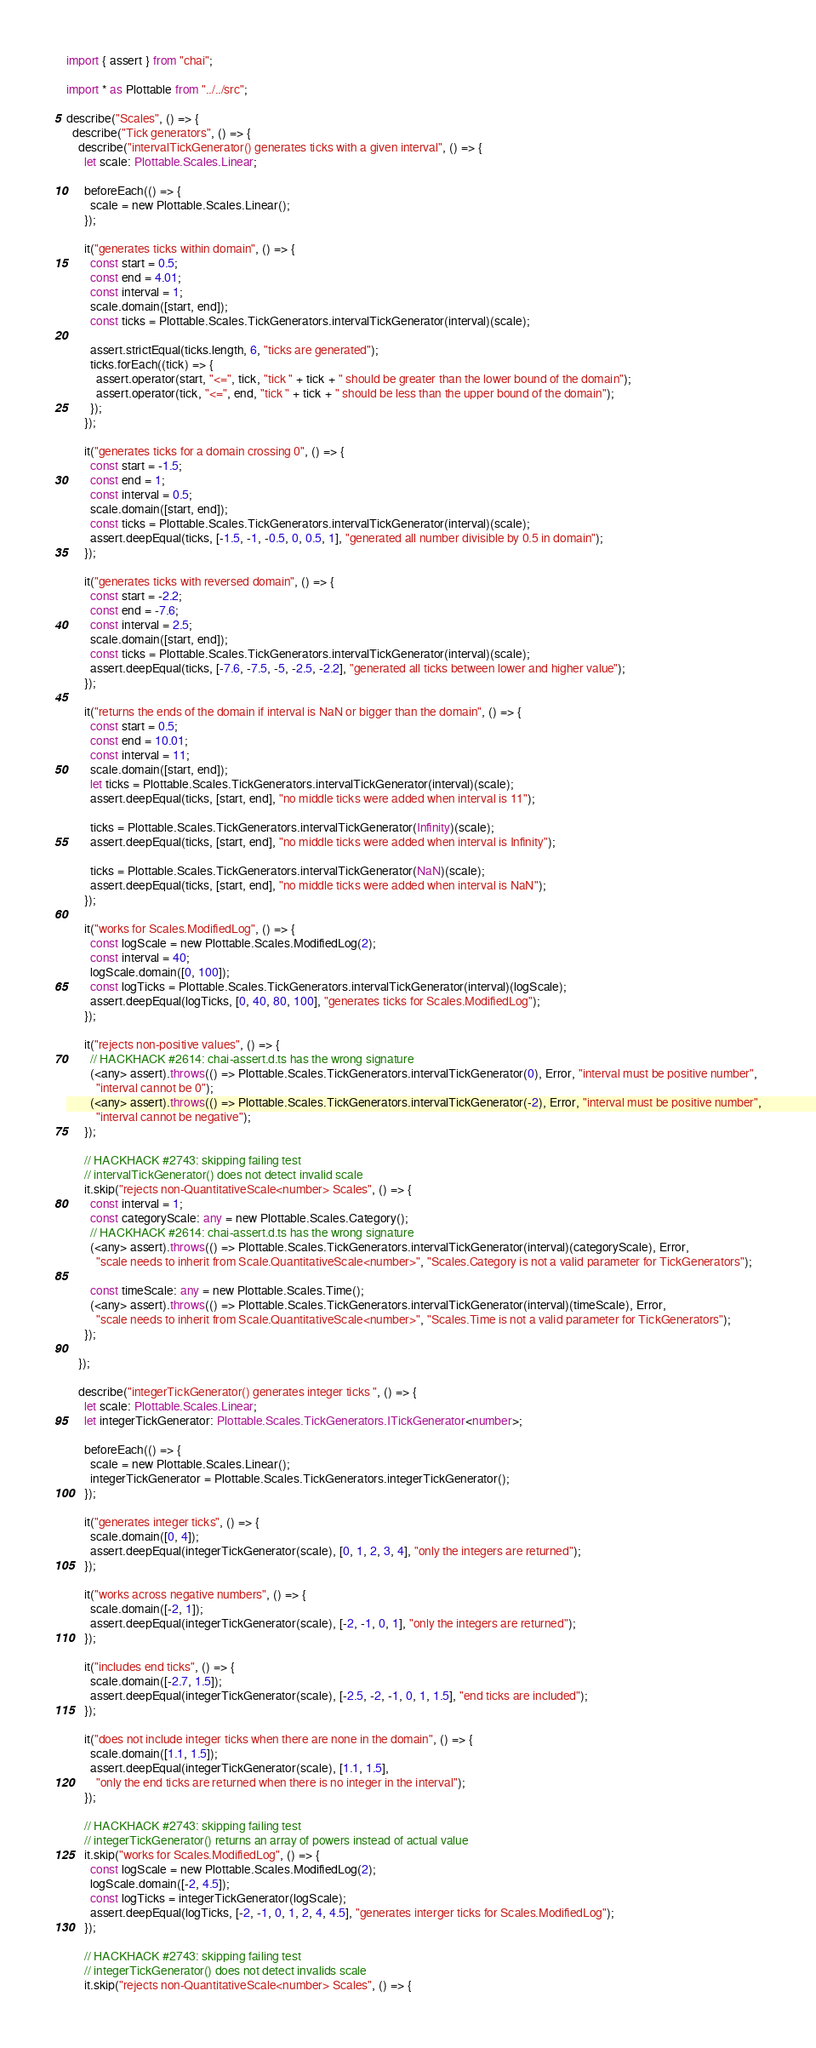<code> <loc_0><loc_0><loc_500><loc_500><_TypeScript_>import { assert } from "chai";

import * as Plottable from "../../src";

describe("Scales", () => {
  describe("Tick generators", () => {
    describe("intervalTickGenerator() generates ticks with a given interval", () => {
      let scale: Plottable.Scales.Linear;

      beforeEach(() => {
        scale = new Plottable.Scales.Linear();
      });

      it("generates ticks within domain", () => {
        const start = 0.5;
        const end = 4.01;
        const interval = 1;
        scale.domain([start, end]);
        const ticks = Plottable.Scales.TickGenerators.intervalTickGenerator(interval)(scale);

        assert.strictEqual(ticks.length, 6, "ticks are generated");
        ticks.forEach((tick) => {
          assert.operator(start, "<=", tick, "tick " + tick + " should be greater than the lower bound of the domain");
          assert.operator(tick, "<=", end, "tick " + tick + " should be less than the upper bound of the domain");
        });
      });

      it("generates ticks for a domain crossing 0", () => {
        const start = -1.5;
        const end = 1;
        const interval = 0.5;
        scale.domain([start, end]);
        const ticks = Plottable.Scales.TickGenerators.intervalTickGenerator(interval)(scale);
        assert.deepEqual(ticks, [-1.5, -1, -0.5, 0, 0.5, 1], "generated all number divisible by 0.5 in domain");
      });

      it("generates ticks with reversed domain", () => {
        const start = -2.2;
        const end = -7.6;
        const interval = 2.5;
        scale.domain([start, end]);
        const ticks = Plottable.Scales.TickGenerators.intervalTickGenerator(interval)(scale);
        assert.deepEqual(ticks, [-7.6, -7.5, -5, -2.5, -2.2], "generated all ticks between lower and higher value");
      });

      it("returns the ends of the domain if interval is NaN or bigger than the domain", () => {
        const start = 0.5;
        const end = 10.01;
        const interval = 11;
        scale.domain([start, end]);
        let ticks = Plottable.Scales.TickGenerators.intervalTickGenerator(interval)(scale);
        assert.deepEqual(ticks, [start, end], "no middle ticks were added when interval is 11");

        ticks = Plottable.Scales.TickGenerators.intervalTickGenerator(Infinity)(scale);
        assert.deepEqual(ticks, [start, end], "no middle ticks were added when interval is Infinity");

        ticks = Plottable.Scales.TickGenerators.intervalTickGenerator(NaN)(scale);
        assert.deepEqual(ticks, [start, end], "no middle ticks were added when interval is NaN");
      });

      it("works for Scales.ModifiedLog", () => {
        const logScale = new Plottable.Scales.ModifiedLog(2);
        const interval = 40;
        logScale.domain([0, 100]);
        const logTicks = Plottable.Scales.TickGenerators.intervalTickGenerator(interval)(logScale);
        assert.deepEqual(logTicks, [0, 40, 80, 100], "generates ticks for Scales.ModifiedLog");
      });

      it("rejects non-positive values", () => {
        // HACKHACK #2614: chai-assert.d.ts has the wrong signature
        (<any> assert).throws(() => Plottable.Scales.TickGenerators.intervalTickGenerator(0), Error, "interval must be positive number",
          "interval cannot be 0");
        (<any> assert).throws(() => Plottable.Scales.TickGenerators.intervalTickGenerator(-2), Error, "interval must be positive number",
          "interval cannot be negative");
      });

      // HACKHACK #2743: skipping failing test
      // intervalTickGenerator() does not detect invalid scale
      it.skip("rejects non-QuantitativeScale<number> Scales", () => {
        const interval = 1;
        const categoryScale: any = new Plottable.Scales.Category();
        // HACKHACK #2614: chai-assert.d.ts has the wrong signature
        (<any> assert).throws(() => Plottable.Scales.TickGenerators.intervalTickGenerator(interval)(categoryScale), Error,
          "scale needs to inherit from Scale.QuantitativeScale<number>", "Scales.Category is not a valid parameter for TickGenerators");

        const timeScale: any = new Plottable.Scales.Time();
        (<any> assert).throws(() => Plottable.Scales.TickGenerators.intervalTickGenerator(interval)(timeScale), Error,
          "scale needs to inherit from Scale.QuantitativeScale<number>", "Scales.Time is not a valid parameter for TickGenerators");
      });

    });

    describe("integerTickGenerator() generates integer ticks ", () => {
      let scale: Plottable.Scales.Linear;
      let integerTickGenerator: Plottable.Scales.TickGenerators.ITickGenerator<number>;

      beforeEach(() => {
        scale = new Plottable.Scales.Linear();
        integerTickGenerator = Plottable.Scales.TickGenerators.integerTickGenerator();
      });

      it("generates integer ticks", () => {
        scale.domain([0, 4]);
        assert.deepEqual(integerTickGenerator(scale), [0, 1, 2, 3, 4], "only the integers are returned");
      });

      it("works across negative numbers", () => {
        scale.domain([-2, 1]);
        assert.deepEqual(integerTickGenerator(scale), [-2, -1, 0, 1], "only the integers are returned");
      });

      it("includes end ticks", () => {
        scale.domain([-2.7, 1.5]);
        assert.deepEqual(integerTickGenerator(scale), [-2.5, -2, -1, 0, 1, 1.5], "end ticks are included");
      });

      it("does not include integer ticks when there are none in the domain", () => {
        scale.domain([1.1, 1.5]);
        assert.deepEqual(integerTickGenerator(scale), [1.1, 1.5],
          "only the end ticks are returned when there is no integer in the interval");
      });

      // HACKHACK #2743: skipping failing test
      // integerTickGenerator() returns an array of powers instead of actual value
      it.skip("works for Scales.ModifiedLog", () => {
        const logScale = new Plottable.Scales.ModifiedLog(2);
        logScale.domain([-2, 4.5]);
        const logTicks = integerTickGenerator(logScale);
        assert.deepEqual(logTicks, [-2, -1, 0, 1, 2, 4, 4.5], "generates interger ticks for Scales.ModifiedLog");
      });

      // HACKHACK #2743: skipping failing test
      // integerTickGenerator() does not detect invalids scale
      it.skip("rejects non-QuantitativeScale<number> Scales", () => {</code> 